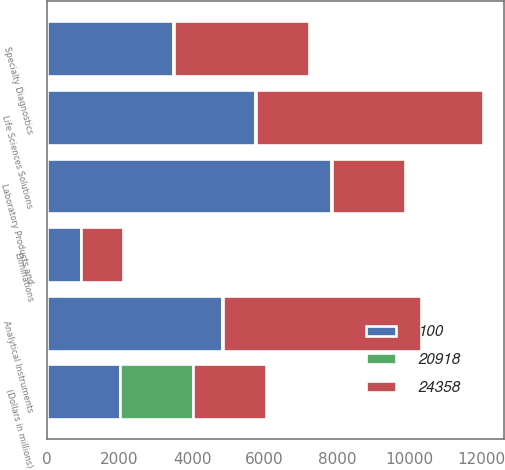Convert chart to OTSL. <chart><loc_0><loc_0><loc_500><loc_500><stacked_bar_chart><ecel><fcel>(Dollars in millions)<fcel>Life Sciences Solutions<fcel>Analytical Instruments<fcel>Specialty Diagnostics<fcel>Laboratory Products and<fcel>Eliminations<nl><fcel>24358<fcel>2018<fcel>6269<fcel>5469<fcel>3724<fcel>2018<fcel>1139<nl><fcel>20918<fcel>2018<fcel>25.7<fcel>22.5<fcel>15.3<fcel>41.2<fcel>4.7<nl><fcel>100<fcel>2017<fcel>5728<fcel>4821<fcel>3486<fcel>7825<fcel>942<nl></chart> 